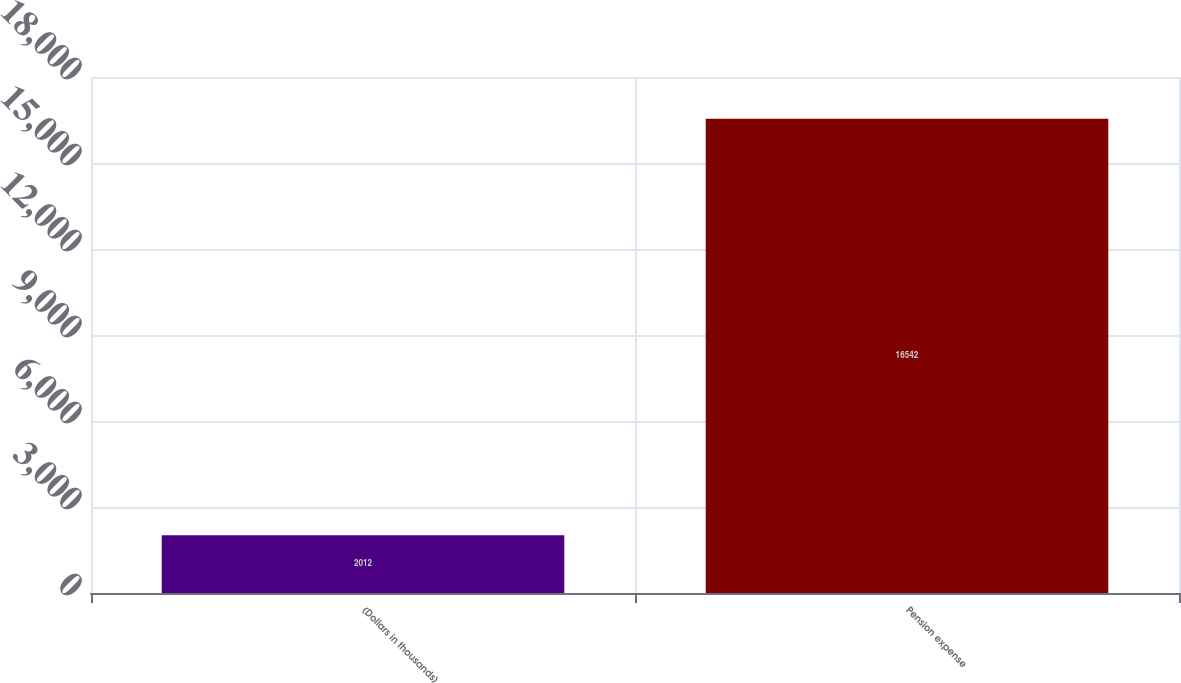Convert chart. <chart><loc_0><loc_0><loc_500><loc_500><bar_chart><fcel>(Dollars in thousands)<fcel>Pension expense<nl><fcel>2012<fcel>16542<nl></chart> 